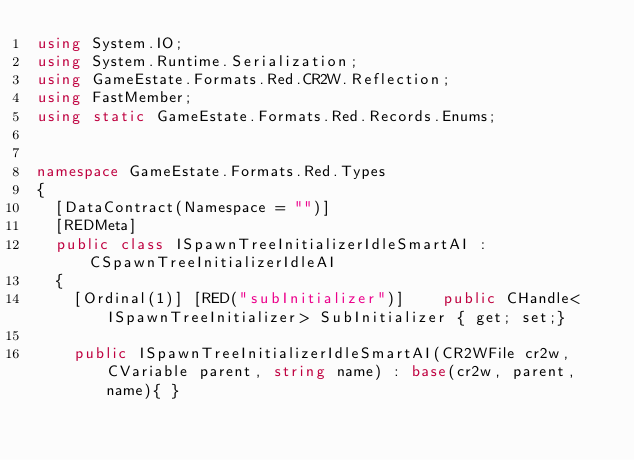<code> <loc_0><loc_0><loc_500><loc_500><_C#_>using System.IO;
using System.Runtime.Serialization;
using GameEstate.Formats.Red.CR2W.Reflection;
using FastMember;
using static GameEstate.Formats.Red.Records.Enums;


namespace GameEstate.Formats.Red.Types
{
	[DataContract(Namespace = "")]
	[REDMeta]
	public class ISpawnTreeInitializerIdleSmartAI : CSpawnTreeInitializerIdleAI
	{
		[Ordinal(1)] [RED("subInitializer")] 		public CHandle<ISpawnTreeInitializer> SubInitializer { get; set;}

		public ISpawnTreeInitializerIdleSmartAI(CR2WFile cr2w, CVariable parent, string name) : base(cr2w, parent, name){ }
</code> 